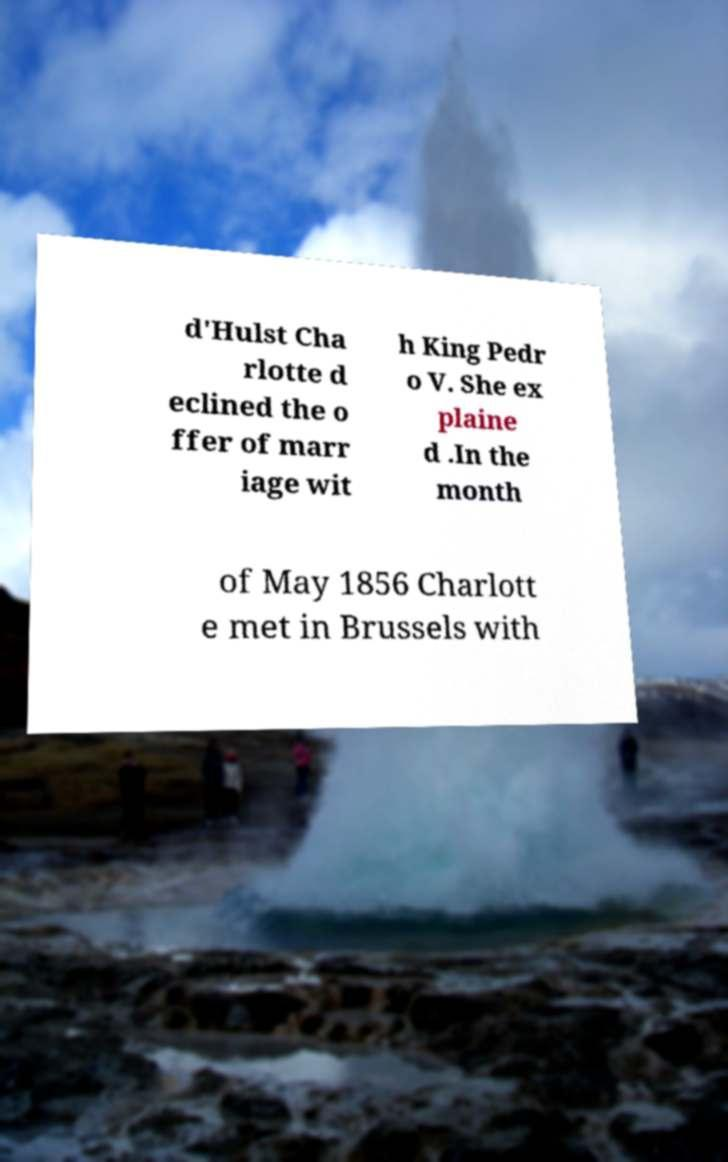Could you extract and type out the text from this image? d'Hulst Cha rlotte d eclined the o ffer of marr iage wit h King Pedr o V. She ex plaine d .In the month of May 1856 Charlott e met in Brussels with 